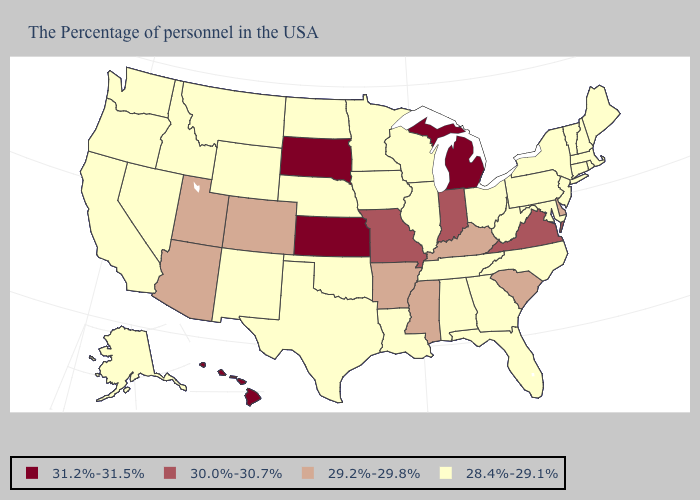Name the states that have a value in the range 29.2%-29.8%?
Be succinct. Delaware, South Carolina, Kentucky, Mississippi, Arkansas, Colorado, Utah, Arizona. Among the states that border Maine , which have the lowest value?
Give a very brief answer. New Hampshire. Does the first symbol in the legend represent the smallest category?
Concise answer only. No. Is the legend a continuous bar?
Answer briefly. No. Does Texas have the same value as Alaska?
Write a very short answer. Yes. Does Delaware have the same value as Utah?
Be succinct. Yes. What is the value of South Carolina?
Concise answer only. 29.2%-29.8%. What is the highest value in the MidWest ?
Keep it brief. 31.2%-31.5%. Which states hav the highest value in the South?
Be succinct. Virginia. What is the lowest value in the Northeast?
Concise answer only. 28.4%-29.1%. Name the states that have a value in the range 28.4%-29.1%?
Quick response, please. Maine, Massachusetts, Rhode Island, New Hampshire, Vermont, Connecticut, New York, New Jersey, Maryland, Pennsylvania, North Carolina, West Virginia, Ohio, Florida, Georgia, Alabama, Tennessee, Wisconsin, Illinois, Louisiana, Minnesota, Iowa, Nebraska, Oklahoma, Texas, North Dakota, Wyoming, New Mexico, Montana, Idaho, Nevada, California, Washington, Oregon, Alaska. Name the states that have a value in the range 31.2%-31.5%?
Concise answer only. Michigan, Kansas, South Dakota, Hawaii. What is the value of New Mexico?
Keep it brief. 28.4%-29.1%. Name the states that have a value in the range 29.2%-29.8%?
Quick response, please. Delaware, South Carolina, Kentucky, Mississippi, Arkansas, Colorado, Utah, Arizona. 